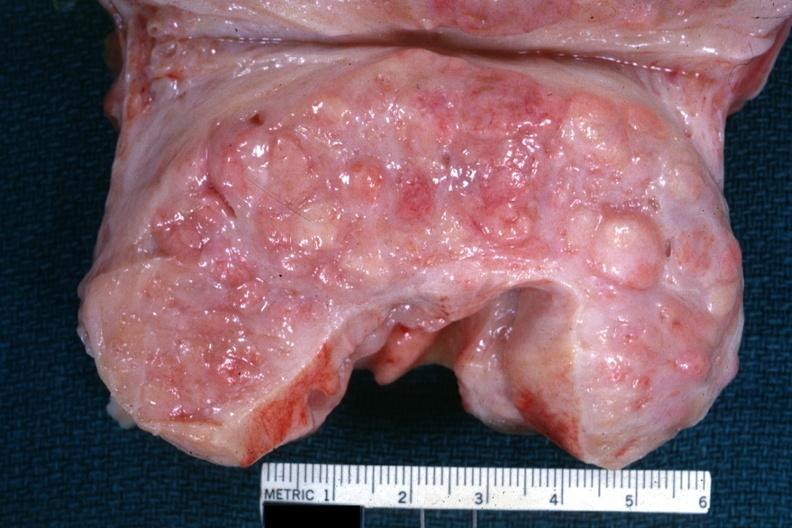how is excellent example cut surface?
Answer the question using a single word or phrase. Nodular hyperplasia 